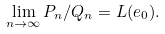Convert formula to latex. <formula><loc_0><loc_0><loc_500><loc_500>\lim _ { n \rightarrow \infty } P _ { n } / Q _ { n } = L ( e _ { 0 } ) .</formula> 